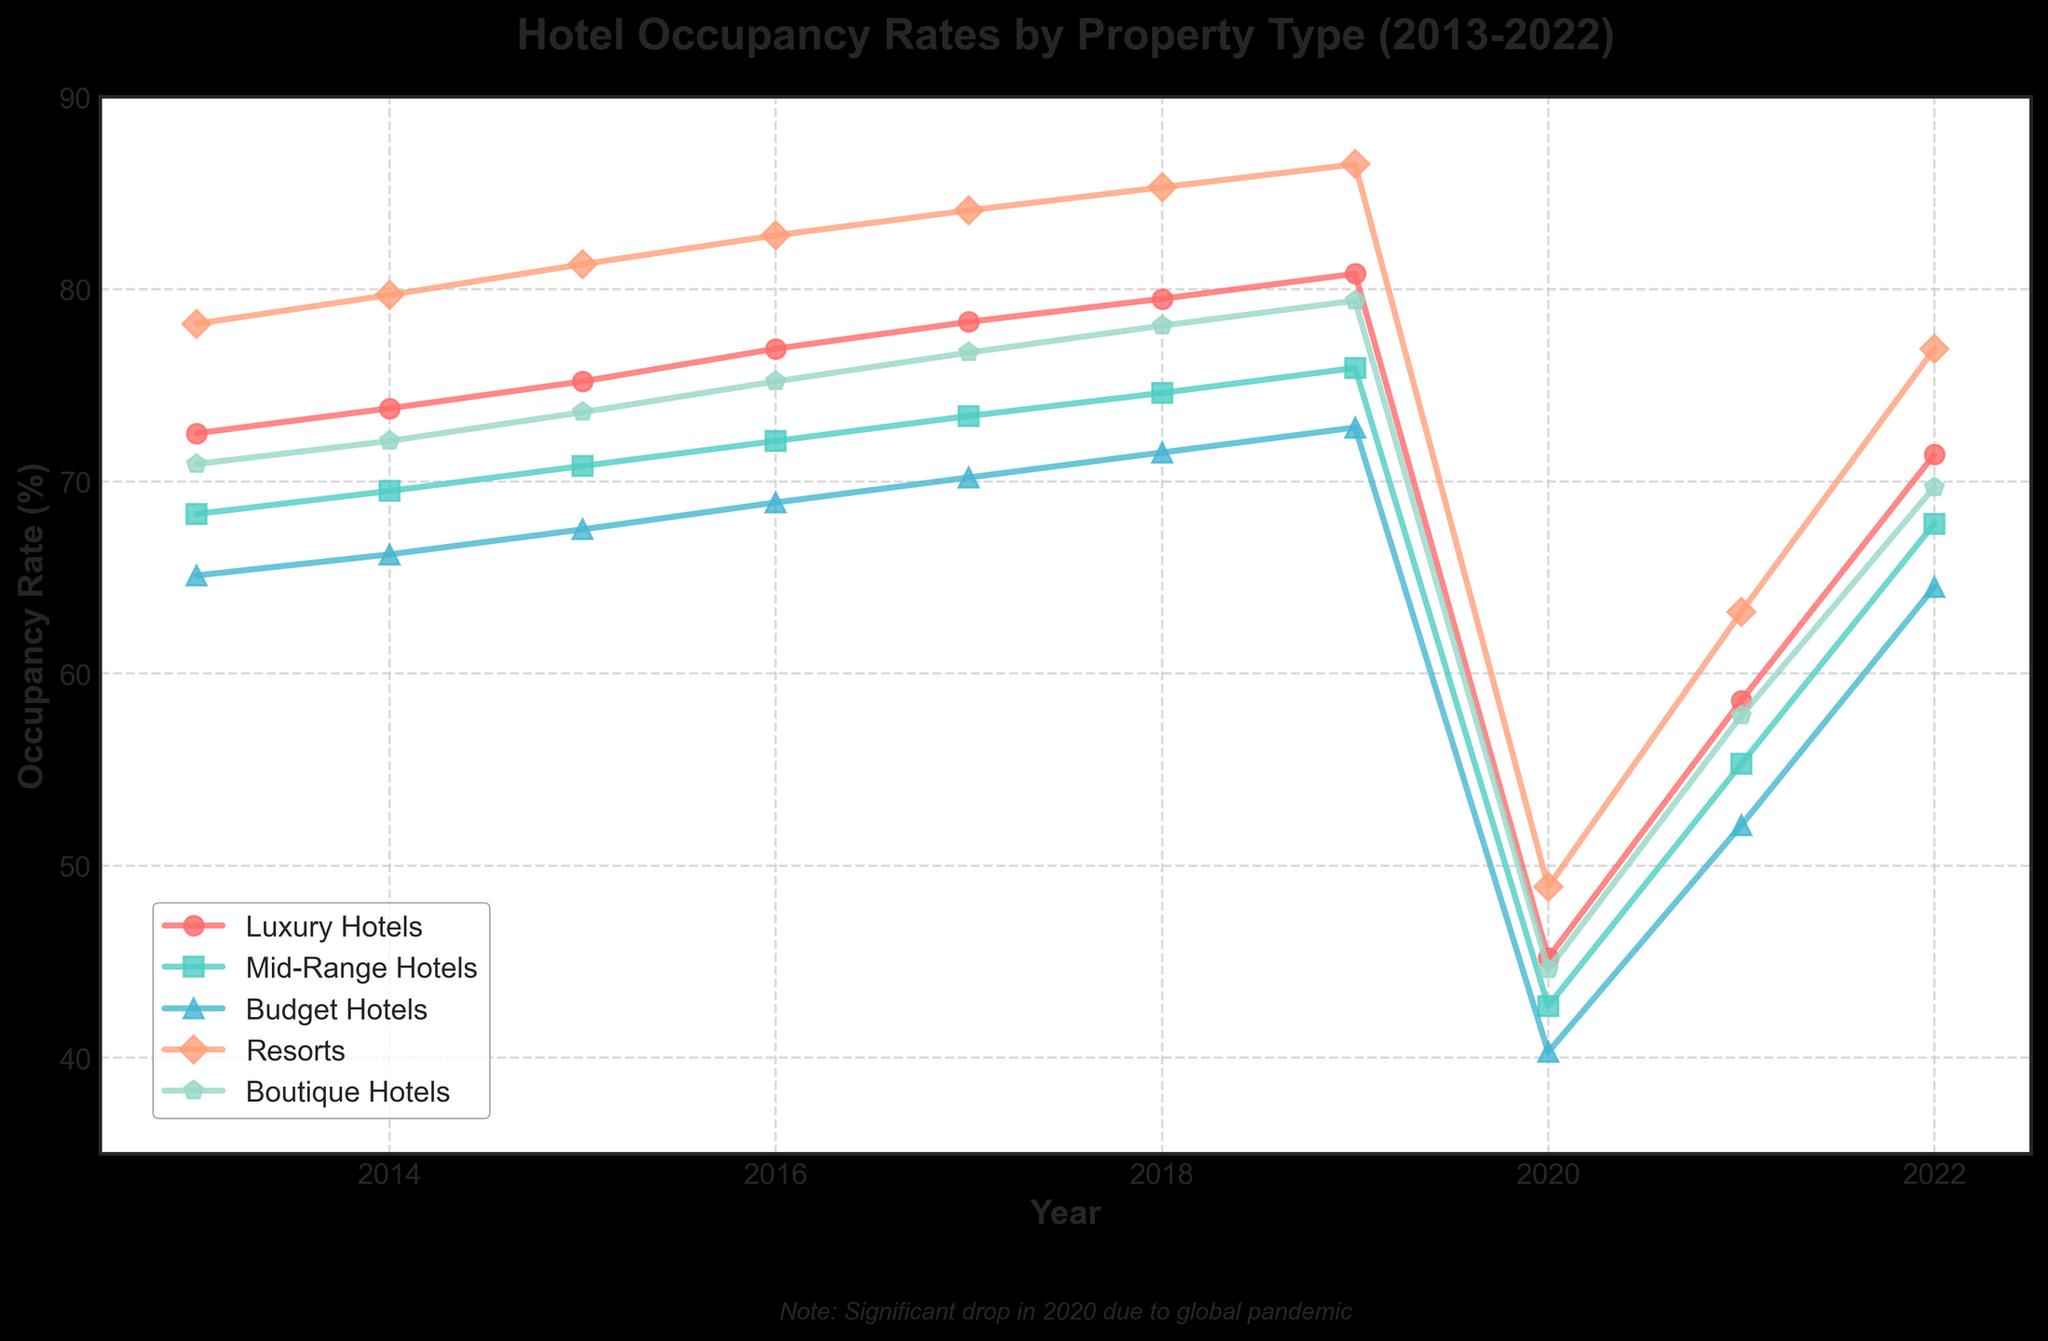What property type had the highest occupancy rate in 2019? Looking at the lines for 2019, Resorts had the highest occupancy rate as indicated by the highest point among all property types.
Answer: Resorts Which type of hotel experienced the largest drop in occupancy rate between 2019 and 2020? Calculate the difference in occupancy rates between 2019 and 2020 for each property type and identify which has the largest decrease. Resorts dropped from 86.5% to 48.9%, a decrease of 37.6%, which is the largest.
Answer: Resorts By how much did the occupancy rate for Mid-Range Hotels increase from 2020 to 2021? Subtract the 2020 occupancy rate (42.7%) for Mid-Range Hotels from the 2021 rate (55.3%). This gives an increase of 12.6%.
Answer: 12.6% What is the average occupancy rate for Boutique Hotels from 2013 to 2022? Sum the occupancy rates of Boutique Hotels from 2013 to 2022 and divide by the number of years (10). The sum is 70.9 + 72.1 + 73.6 + 75.2 + 76.7 + 78.1 + 79.4 + 44.6 + 57.8 + 69.7 = 698.1. Thus, the average is 698.1 / 10 = 69.81%.
Answer: 69.81% Which type of hotel had a greater rate of recovery in occupancy from 2020 to 2022, Budget Hotels or Luxury Hotels? Calculate the difference in occupancy rates from 2020 to 2022 for both Budget Hotels (64.5% - 40.3% = 24.2%) and Luxury Hotels (71.4% - 45.2% = 26.2%). Luxury Hotels had a greater rate of recovery.
Answer: Luxury Hotels Which years did Mid-Range Hotels have a higher occupancy rate than Boutique Hotels? Compare the occupancy rates between Mid-Range Hotels and Boutique Hotels year by year. For the years 2013, 2014, 2015, 2021, and 2022, Mid-Range Hotels had higher occupancy rates than Boutique Hotels.
Answer: 2013, 2014, 2015, 2021, 2022 In which year did Luxury Hotels reach their peak occupancy rate? Looking at the plot for Luxury Hotels, the highest occupancy rate occurred in 2019.
Answer: 2019 